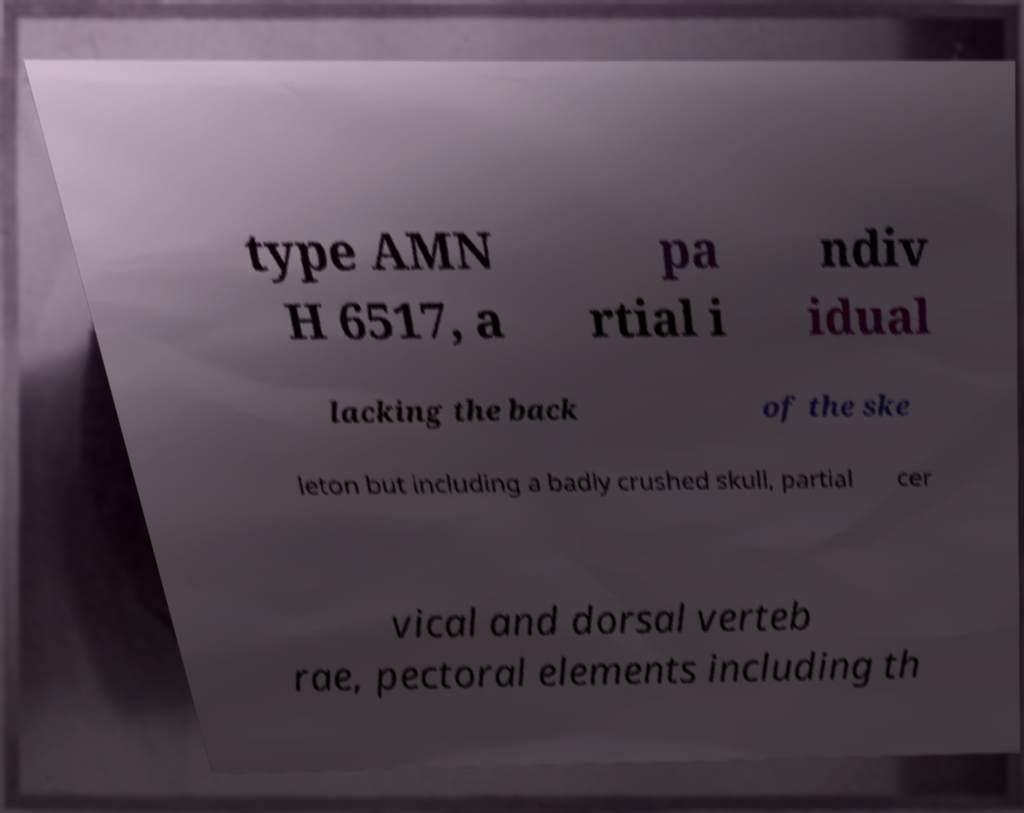What messages or text are displayed in this image? I need them in a readable, typed format. type AMN H 6517, a pa rtial i ndiv idual lacking the back of the ske leton but including a badly crushed skull, partial cer vical and dorsal verteb rae, pectoral elements including th 